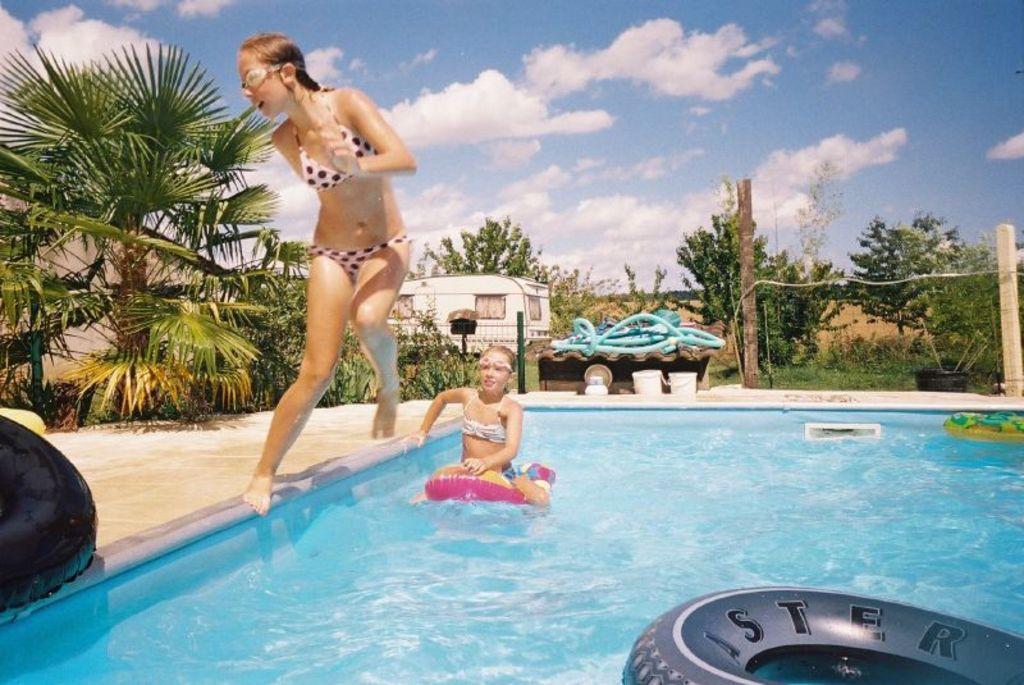Describe this image in one or two sentences. In this image, we can see a few people. We can see the ground with some objects. We can see some water with some objects like tubes. We can see some pipes, buckets. We can see some wooden poles. There are a few trees, plants. We can see some grass and the wall. We can see the sky with clouds. 